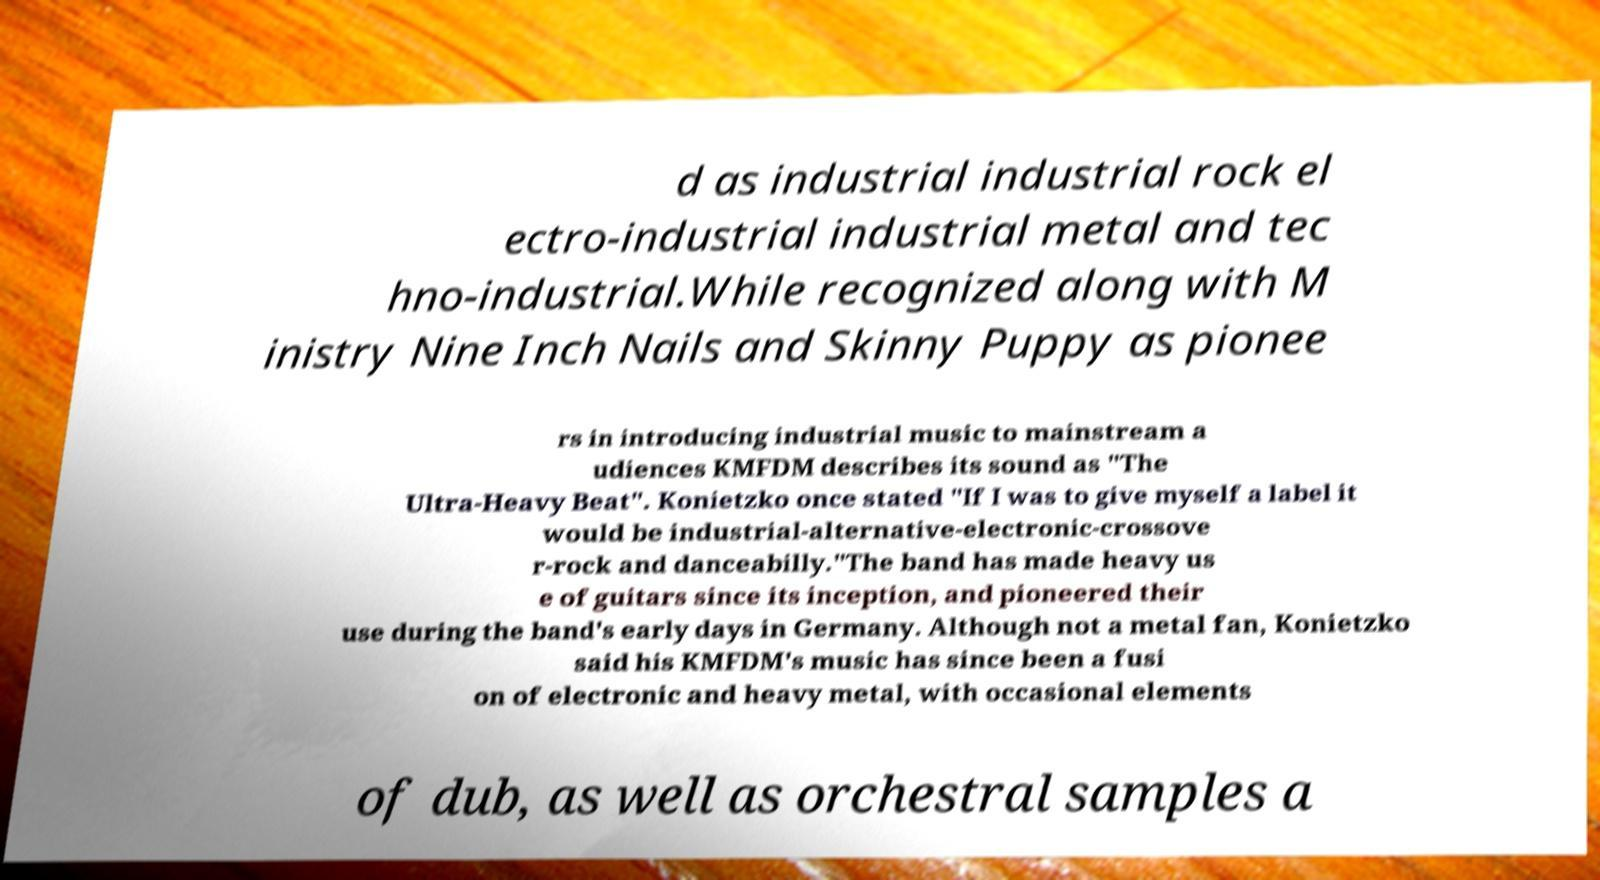Can you read and provide the text displayed in the image?This photo seems to have some interesting text. Can you extract and type it out for me? d as industrial industrial rock el ectro-industrial industrial metal and tec hno-industrial.While recognized along with M inistry Nine Inch Nails and Skinny Puppy as pionee rs in introducing industrial music to mainstream a udiences KMFDM describes its sound as "The Ultra-Heavy Beat". Konietzko once stated "If I was to give myself a label it would be industrial-alternative-electronic-crossove r-rock and danceabilly."The band has made heavy us e of guitars since its inception, and pioneered their use during the band's early days in Germany. Although not a metal fan, Konietzko said his KMFDM's music has since been a fusi on of electronic and heavy metal, with occasional elements of dub, as well as orchestral samples a 